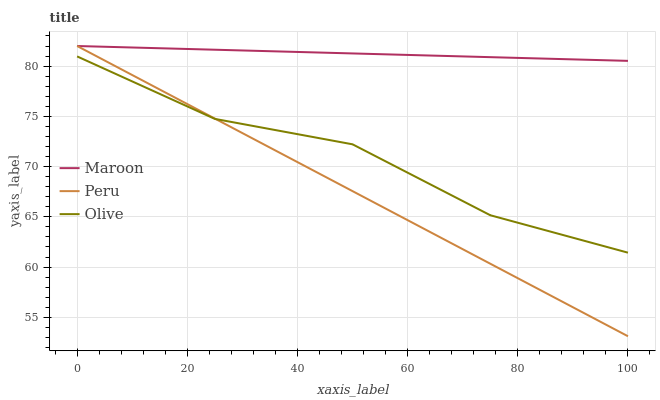Does Peru have the minimum area under the curve?
Answer yes or no. Yes. Does Maroon have the maximum area under the curve?
Answer yes or no. Yes. Does Maroon have the minimum area under the curve?
Answer yes or no. No. Does Peru have the maximum area under the curve?
Answer yes or no. No. Is Peru the smoothest?
Answer yes or no. Yes. Is Olive the roughest?
Answer yes or no. Yes. Is Maroon the roughest?
Answer yes or no. No. Does Peru have the lowest value?
Answer yes or no. Yes. Does Maroon have the lowest value?
Answer yes or no. No. Does Maroon have the highest value?
Answer yes or no. Yes. Is Olive less than Maroon?
Answer yes or no. Yes. Is Maroon greater than Olive?
Answer yes or no. Yes. Does Maroon intersect Peru?
Answer yes or no. Yes. Is Maroon less than Peru?
Answer yes or no. No. Is Maroon greater than Peru?
Answer yes or no. No. Does Olive intersect Maroon?
Answer yes or no. No. 